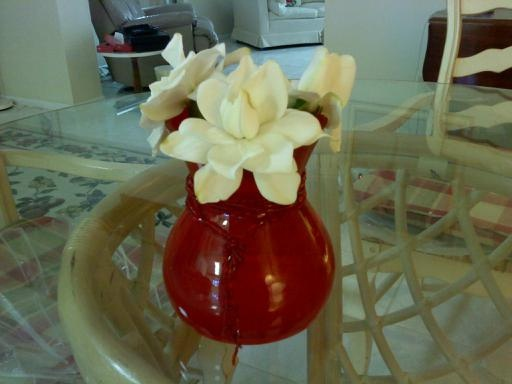Describe the objects in this image and their specific colors. I can see dining table in gray, darkgreen, and black tones, vase in gray and maroon tones, chair in gray, darkgray, and olive tones, couch in gray, teal, and darkgray tones, and chair in gray, teal, darkgray, and black tones in this image. 